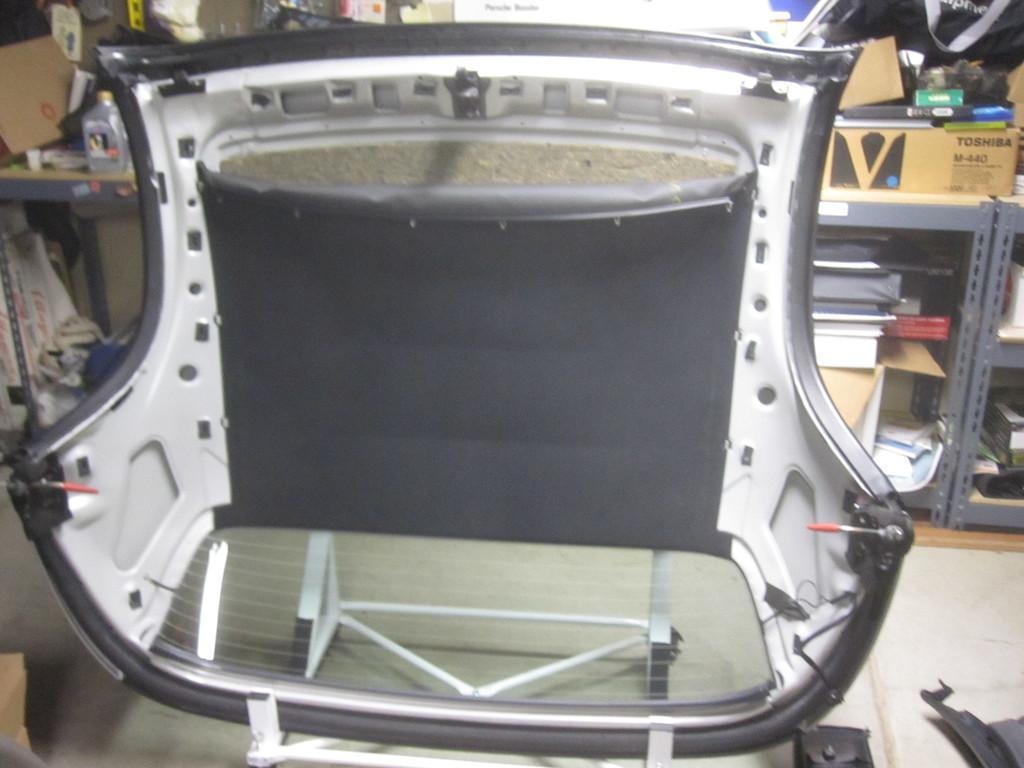Can you describe this image briefly? In this picture we can see a chair on the floor and in the background we can see racks, books, boxes and some objects. 